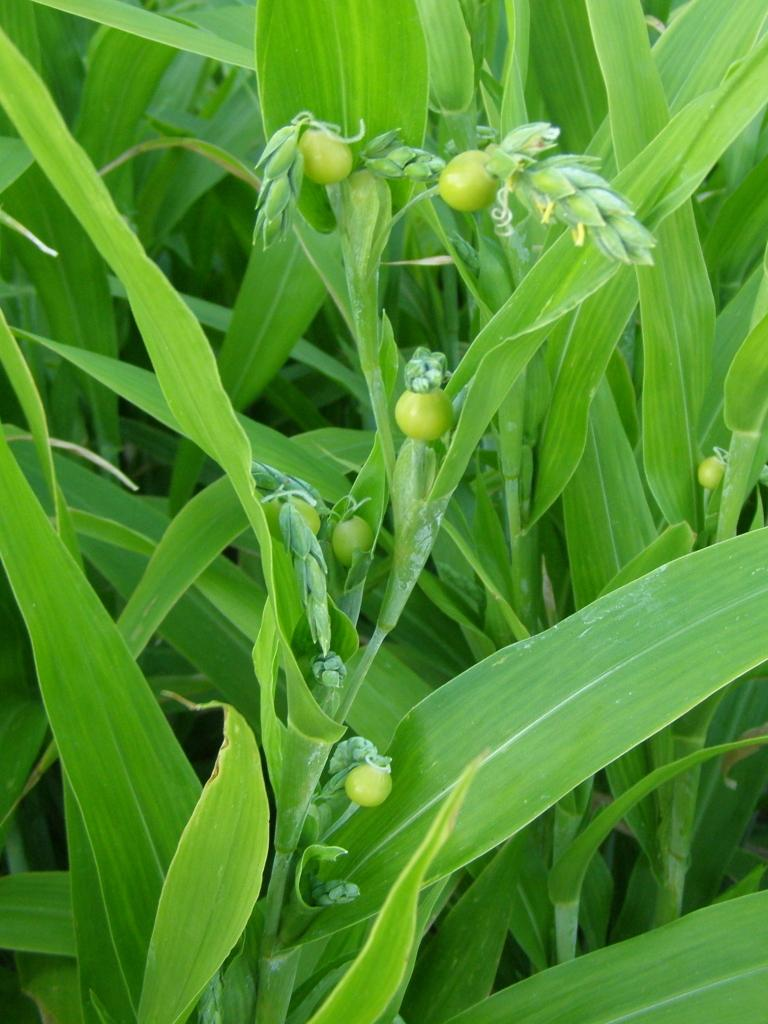What type of living organisms can be seen in the image? Plants can be seen in the image. What color are the leaves of the plants in the image? The leaves of the plants in the image are green. What type of surprise can be seen in the image involving geese? There is no surprise or geese present in the image; it only features plants with green leaves. 